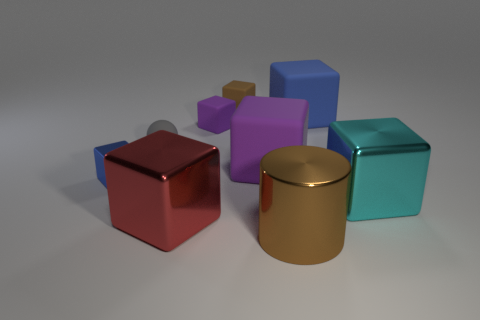Subtract 4 cubes. How many cubes are left? 3 Subtract all big cyan blocks. How many blocks are left? 6 Subtract all brown blocks. How many blocks are left? 6 Subtract all cyan cubes. Subtract all yellow balls. How many cubes are left? 6 Add 1 red matte balls. How many objects exist? 10 Subtract all spheres. How many objects are left? 8 Subtract 0 green cylinders. How many objects are left? 9 Subtract all large yellow shiny cylinders. Subtract all tiny shiny blocks. How many objects are left? 8 Add 2 large brown shiny cylinders. How many large brown shiny cylinders are left? 3 Add 4 small purple matte cylinders. How many small purple matte cylinders exist? 4 